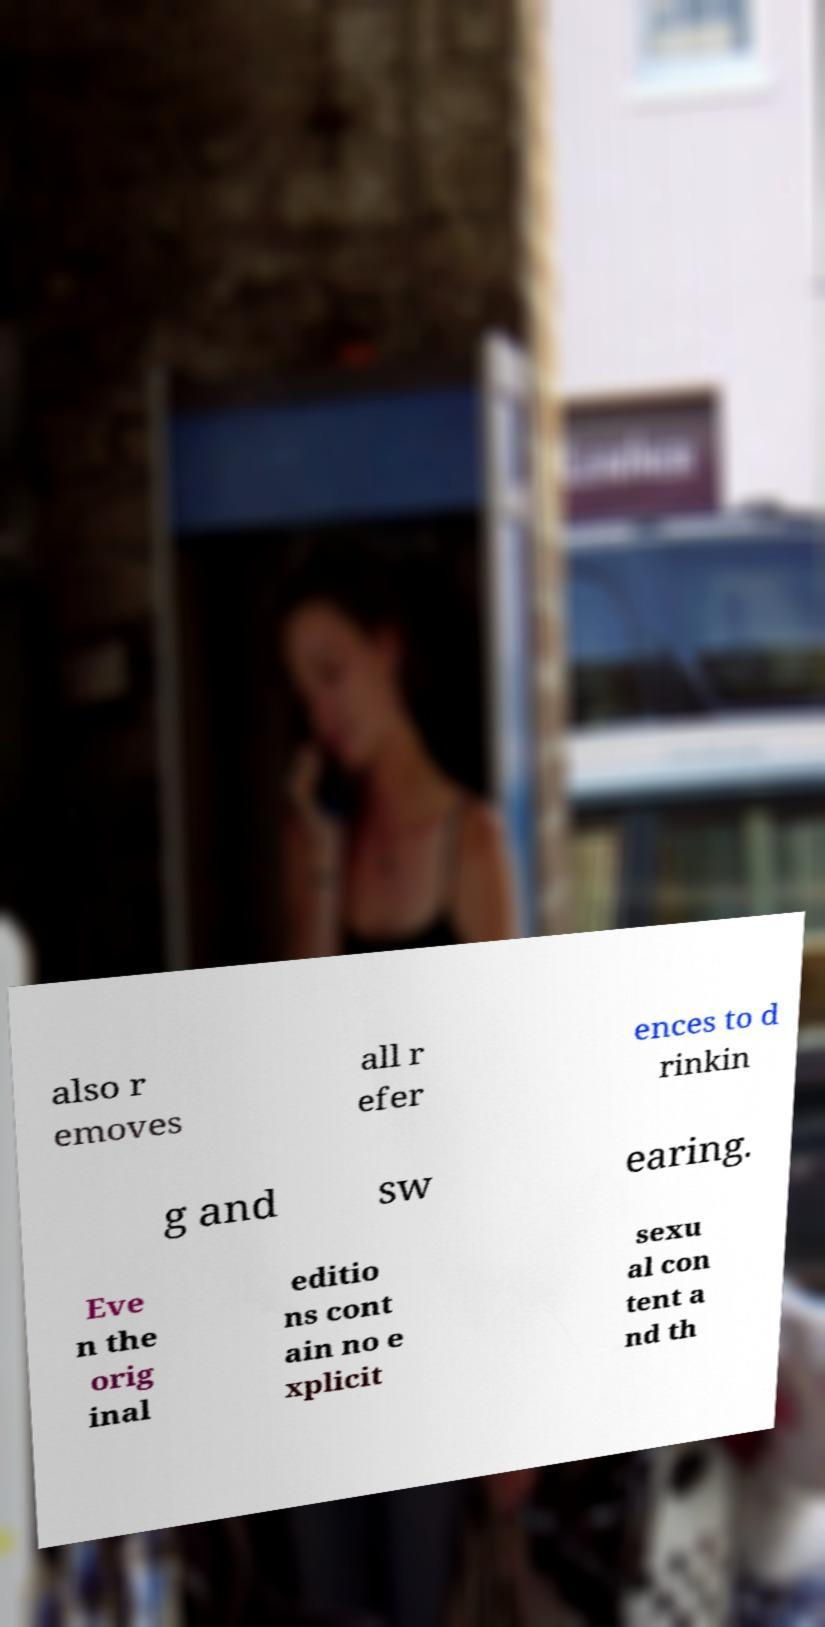Could you assist in decoding the text presented in this image and type it out clearly? also r emoves all r efer ences to d rinkin g and sw earing. Eve n the orig inal editio ns cont ain no e xplicit sexu al con tent a nd th 